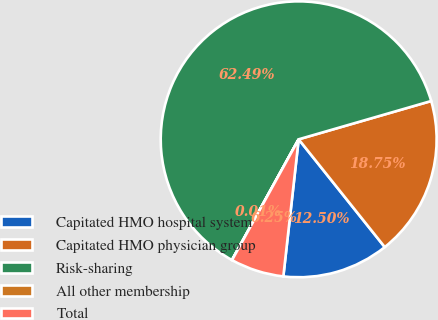Convert chart to OTSL. <chart><loc_0><loc_0><loc_500><loc_500><pie_chart><fcel>Capitated HMO hospital system<fcel>Capitated HMO physician group<fcel>Risk-sharing<fcel>All other membership<fcel>Total<nl><fcel>12.5%<fcel>18.75%<fcel>62.49%<fcel>0.01%<fcel>6.25%<nl></chart> 